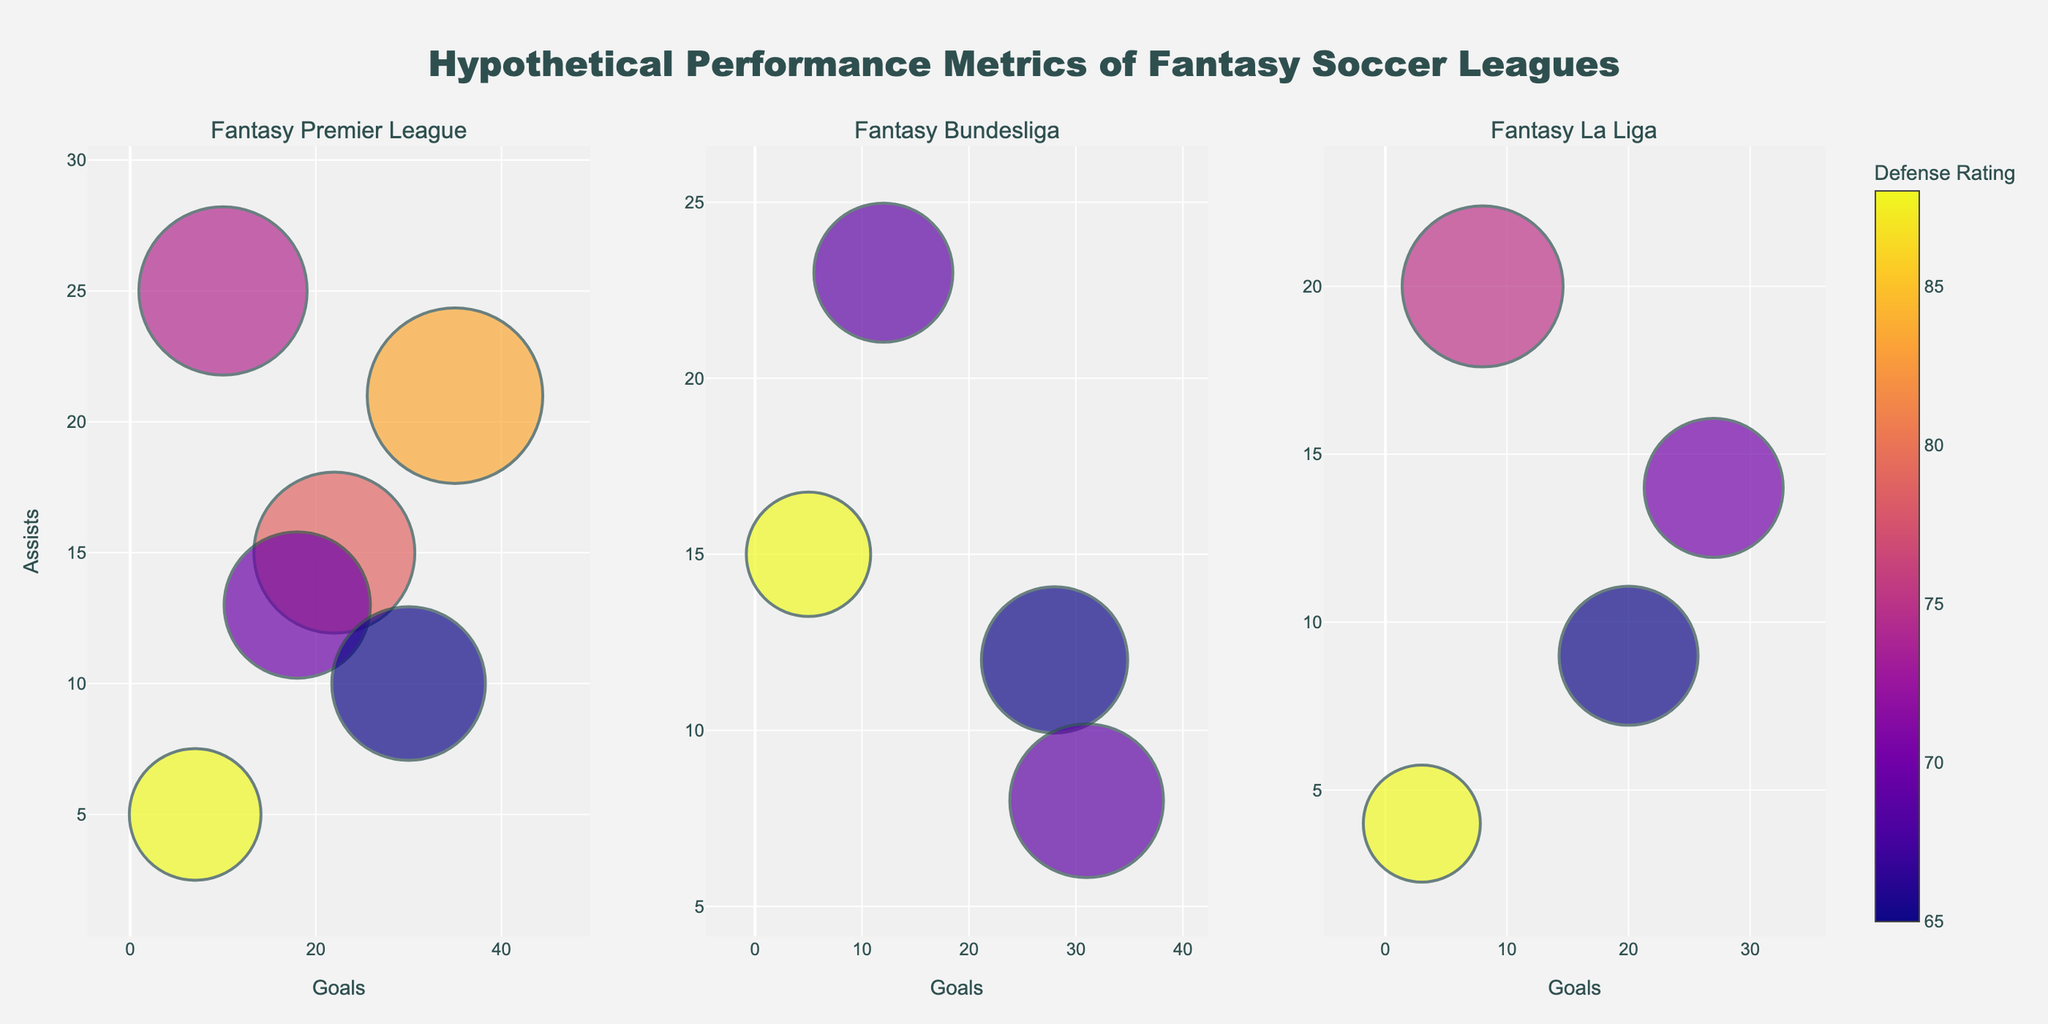What's the title of the figure? The title is usually located at the top of the figure. In this case, it states "Hypothetical Performance Metrics of Fantasy Soccer Leagues."
Answer: Hypothetical Performance Metrics of Fantasy Soccer Leagues How many players are represented from Universe A in the Fantasy Premier League subplot? Look for the players with "Universe A" in the text information when hovering over the bubbles in the Fantasy Premier League subplot. There are three such players.
Answer: 3 Which player in the Fantasy Bundesliga subplot has the highest number of assists and from which universe is he? Look at the y-axis for the highest value and hover over the bubbles in the Fantasy Bundesliga subplot. Thomas Muller with 23 assists from Universe B has the highest.
Answer: Thomas Muller, Universe B Which player has the highest defense rating across all subplots? Check the color of the bubbles in all subplots, with darker colors representing higher defense ratings. Virgil van Dijk in Fantasy Premier League has the highest defense rating at 90.
Answer: Virgil van Dijk Compare the goals and assists of Lionel Messi in the Fantasy Premier League with Karim Benzema in Fantasy La Liga. Who performs better overall? Refer to the goals (x-axis) and assists (y-axis) in the respective subplots. Messi has 35 goals and 21 assists, while Benzema has 27 goals and 14 assists. Messi outperforms Benzema in both metrics.
Answer: Lionel Messi performs better overall What's the median number of goals for players in the Fantasy La Liga subplot? Sort the number of goals for players in Fantasy La Liga (27, 8, 3, 20). Since there are four data points, the median is the average of the two middle numbers, (8 + 20) / 2 = 14.
Answer: 14 Which player from Universe B has the largest bubble size in the Fantasy Premier League subplot? Look for players from Universe B in the Fantasy Premier League subplot and compare bubble sizes. Kevin De Bruyne has the largest bubble size of 115.
Answer: Kevin De Bruyne Which league has the highest number of total goals scored? Sum the goals from each subplot: Fantasy Premier League (35+22+18+30+10+7=122), Fantasy Bundesliga (28+12+5+31=76), Fantasy La Liga (27+8+3+20=58). The Fantasy Premier League has the highest total.
Answer: Fantasy Premier League Who has a bubble size of 105 in Fantasy Bundesliga, and what are their respective goals and assists? Locate the bubble with size 105 in Fantasy Bundesliga. It belongs to Robert Lewandowski, who has 31 goals and 8 assists.
Answer: Robert Lewandowski, 31 goals, 8 assists Which player in Fantasy La Liga is from Universe C, and what are his performance metrics? Check for the player from Universe C in the Fantasy La Liga subplot. Joao Felix has 20 goals, 9 assists, and a defense rating of 65.
Answer: Joao Felix, 20 goals, 9 assists 